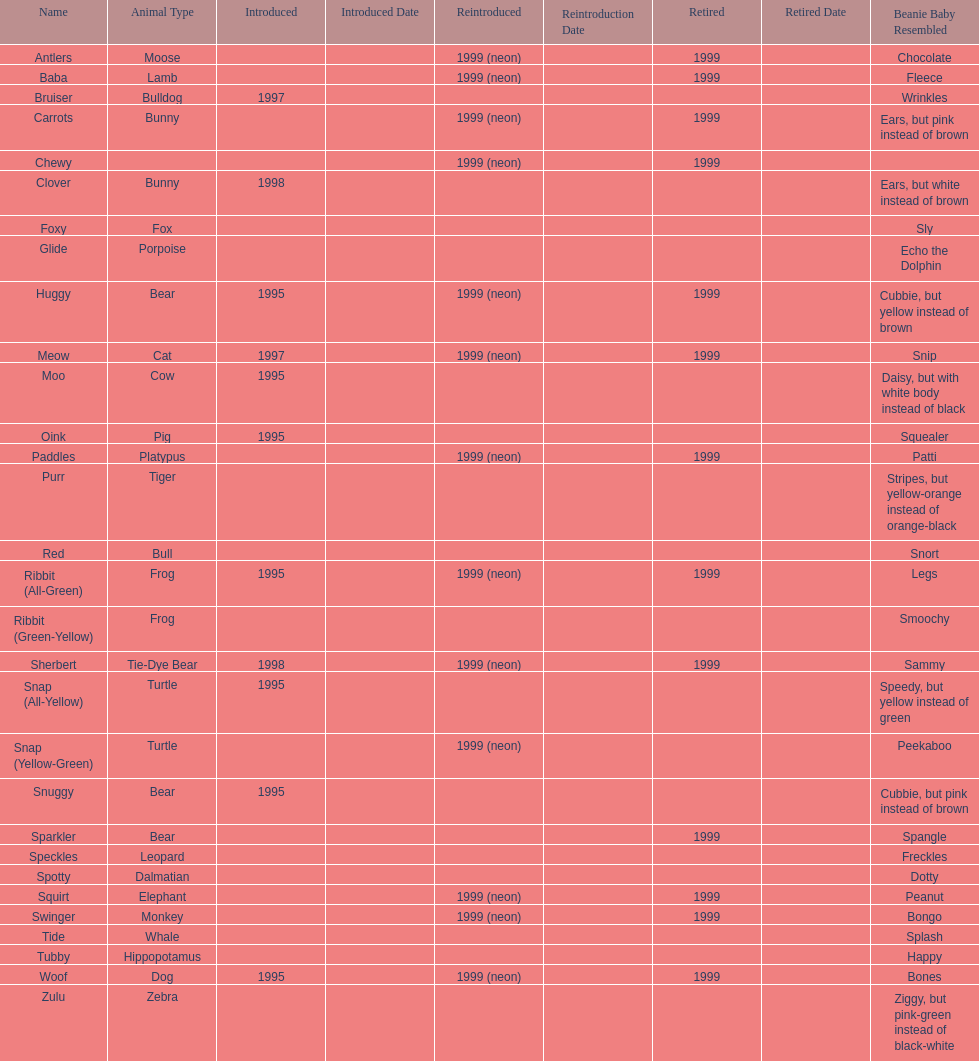In what year were the first pillow pals introduced? 1995. 